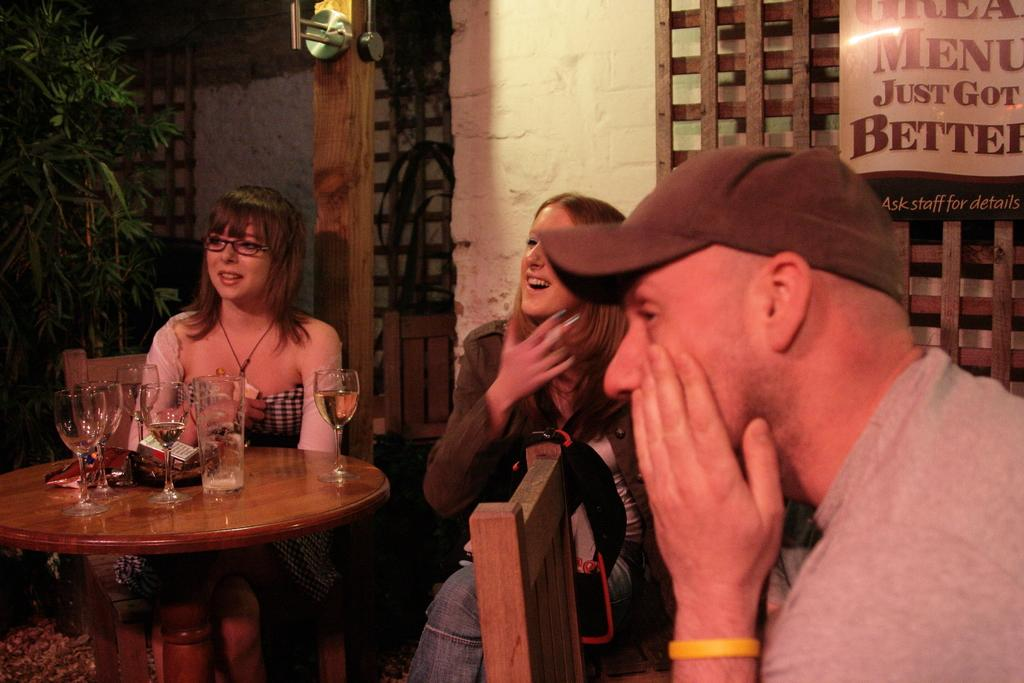How many people are in the image? There are three people in the image. What are the people doing in the image? The people are sitting on a chair. What is in front of the chair? There is a table in front of the chair. What can be seen on the table? Wine glasses are present on the table. What is beside the table? There is a tree beside the table. Are there any cobwebs visible on the tree in the image? There is no mention of cobwebs in the provided facts, and therefore we cannot determine if any are present on the tree. 